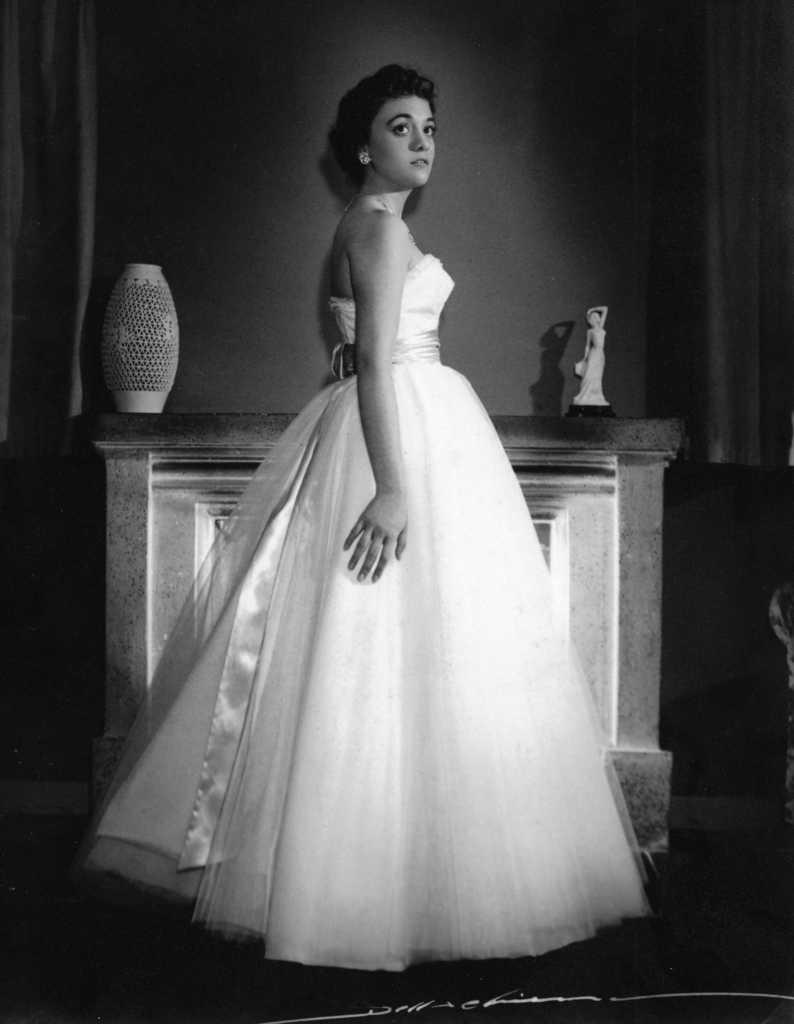What is the main subject of the image? There is a woman standing in the image. What can be seen in the background of the image? There is a statue, an object on a surface, and a wall in the background of the image. Is there any text present in the image? Yes, there is text at the bottom of the image. What type of linen is the woman wearing in the image? There is no information about the woman's clothing in the image, so it cannot be determined if she is wearing linen. Can you describe the woman's reaction in the image? The image does not show the woman's facial expression or any indication of her reaction, so it cannot be described. 